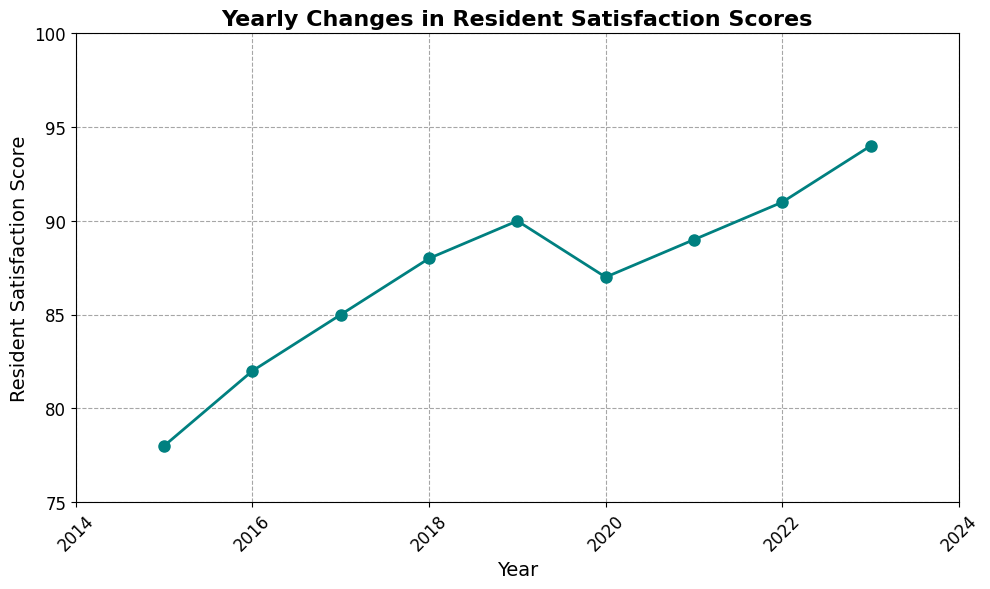What is the trend of Resident Satisfaction Scores from 2015 to 2023? The line chart shows a generally increasing trend from 2015 to 2023, except for a slight dip in 2020.
Answer: Increasing In which year did the Resident Satisfaction Score decrease? By examining the chart, the year 2020 shows a slight decrease compared to 2019.
Answer: 2020 What is the difference in Resident Satisfaction Scores between 2015 and 2023? The score in 2015 is 78, and in 2023 it is 94. The difference is 94 - 78 = 16.
Answer: 16 Which year has the highest Resident Satisfaction Score? The highest point on the chart corresponds to the year 2023 with a score of 94.
Answer: 2023 Between which years did the Resident Satisfaction Score increase the most? The highest increase appears between 2022 and 2023, where the score increased from 91 to 94, a jump of 3 points.
Answer: Between 2022 and 2023 What is the average Resident Satisfaction Score from 2015 to 2023? Add the scores from each year (78, 82, 85, 88, 90, 87, 89, 91, 94) to get a total of 684. Then, divide by the number of years (9): 684 / 9 = 76.
Answer: 76 How many years show an increase in Resident Satisfaction Score? Count the segments in the line that trend upward: From 2015-2016, 2016-2017, 2017-2018, 2018-2019, 2020-2021, 2021-2022, and 2022-2023. There are 7 such years.
Answer: 7 What is the median Resident Satisfaction Score for the period from 2015 to 2023? Arrange the scores in ascending order: 78, 82, 85, 87, 88, 89, 90, 91, 94. The middle value (5th in ascending order) is 88.
Answer: 88 